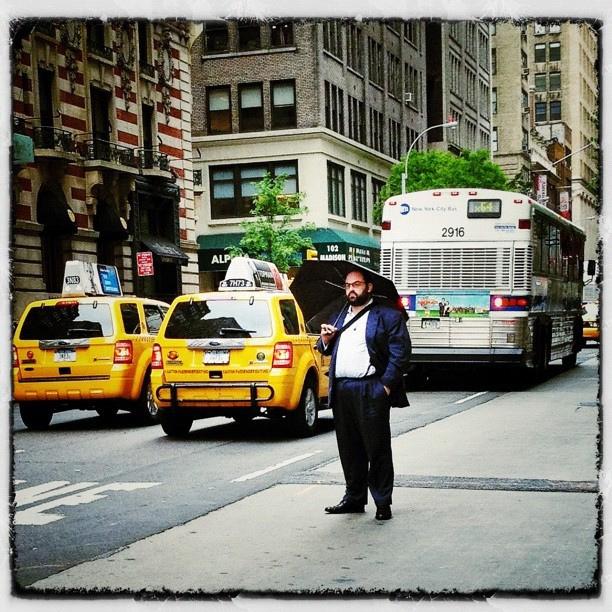Is it raining?
Be succinct. No. What is the four digit number on the back of the bus?
Keep it brief. 2916. Is the setting a big city or small town?
Give a very brief answer. Big city. Is the taxi moving?
Concise answer only. No. 